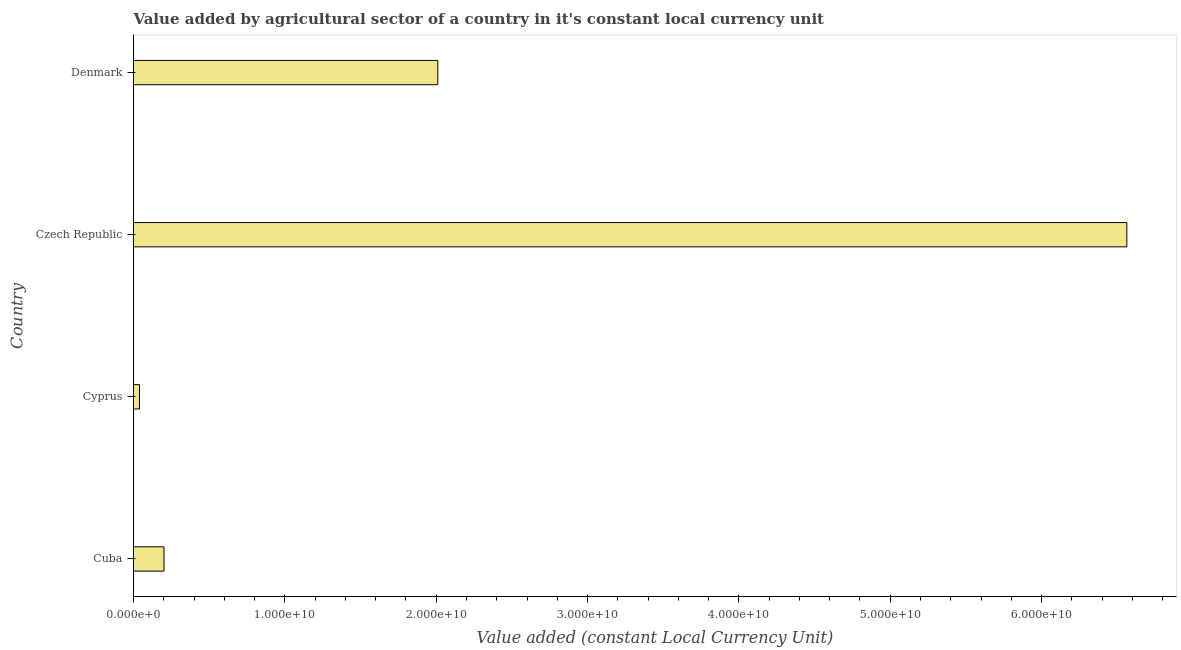Does the graph contain any zero values?
Keep it short and to the point. No. What is the title of the graph?
Ensure brevity in your answer.  Value added by agricultural sector of a country in it's constant local currency unit. What is the label or title of the X-axis?
Keep it short and to the point. Value added (constant Local Currency Unit). What is the label or title of the Y-axis?
Your response must be concise. Country. What is the value added by agriculture sector in Cuba?
Your response must be concise. 2.01e+09. Across all countries, what is the maximum value added by agriculture sector?
Your answer should be compact. 6.56e+1. Across all countries, what is the minimum value added by agriculture sector?
Your answer should be compact. 3.96e+08. In which country was the value added by agriculture sector maximum?
Offer a terse response. Czech Republic. In which country was the value added by agriculture sector minimum?
Keep it short and to the point. Cyprus. What is the sum of the value added by agriculture sector?
Your answer should be compact. 8.81e+1. What is the difference between the value added by agriculture sector in Cuba and Cyprus?
Make the answer very short. 1.62e+09. What is the average value added by agriculture sector per country?
Provide a short and direct response. 2.20e+1. What is the median value added by agriculture sector?
Keep it short and to the point. 1.11e+1. What is the ratio of the value added by agriculture sector in Cuba to that in Czech Republic?
Your answer should be compact. 0.03. Is the difference between the value added by agriculture sector in Cyprus and Czech Republic greater than the difference between any two countries?
Offer a terse response. Yes. What is the difference between the highest and the second highest value added by agriculture sector?
Ensure brevity in your answer.  4.55e+1. Is the sum of the value added by agriculture sector in Cyprus and Denmark greater than the maximum value added by agriculture sector across all countries?
Your answer should be compact. No. What is the difference between the highest and the lowest value added by agriculture sector?
Offer a very short reply. 6.52e+1. In how many countries, is the value added by agriculture sector greater than the average value added by agriculture sector taken over all countries?
Your answer should be compact. 1. Are all the bars in the graph horizontal?
Make the answer very short. Yes. Are the values on the major ticks of X-axis written in scientific E-notation?
Offer a very short reply. Yes. What is the Value added (constant Local Currency Unit) in Cuba?
Offer a terse response. 2.01e+09. What is the Value added (constant Local Currency Unit) in Cyprus?
Keep it short and to the point. 3.96e+08. What is the Value added (constant Local Currency Unit) of Czech Republic?
Keep it short and to the point. 6.56e+1. What is the Value added (constant Local Currency Unit) of Denmark?
Give a very brief answer. 2.01e+1. What is the difference between the Value added (constant Local Currency Unit) in Cuba and Cyprus?
Your answer should be very brief. 1.62e+09. What is the difference between the Value added (constant Local Currency Unit) in Cuba and Czech Republic?
Ensure brevity in your answer.  -6.36e+1. What is the difference between the Value added (constant Local Currency Unit) in Cuba and Denmark?
Make the answer very short. -1.81e+1. What is the difference between the Value added (constant Local Currency Unit) in Cyprus and Czech Republic?
Your answer should be compact. -6.52e+1. What is the difference between the Value added (constant Local Currency Unit) in Cyprus and Denmark?
Give a very brief answer. -1.97e+1. What is the difference between the Value added (constant Local Currency Unit) in Czech Republic and Denmark?
Give a very brief answer. 4.55e+1. What is the ratio of the Value added (constant Local Currency Unit) in Cuba to that in Cyprus?
Offer a very short reply. 5.09. What is the ratio of the Value added (constant Local Currency Unit) in Cuba to that in Czech Republic?
Provide a short and direct response. 0.03. What is the ratio of the Value added (constant Local Currency Unit) in Cuba to that in Denmark?
Make the answer very short. 0.1. What is the ratio of the Value added (constant Local Currency Unit) in Cyprus to that in Czech Republic?
Keep it short and to the point. 0.01. What is the ratio of the Value added (constant Local Currency Unit) in Czech Republic to that in Denmark?
Your answer should be very brief. 3.26. 